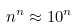<formula> <loc_0><loc_0><loc_500><loc_500>n ^ { n } \approx 1 0 ^ { n }</formula> 